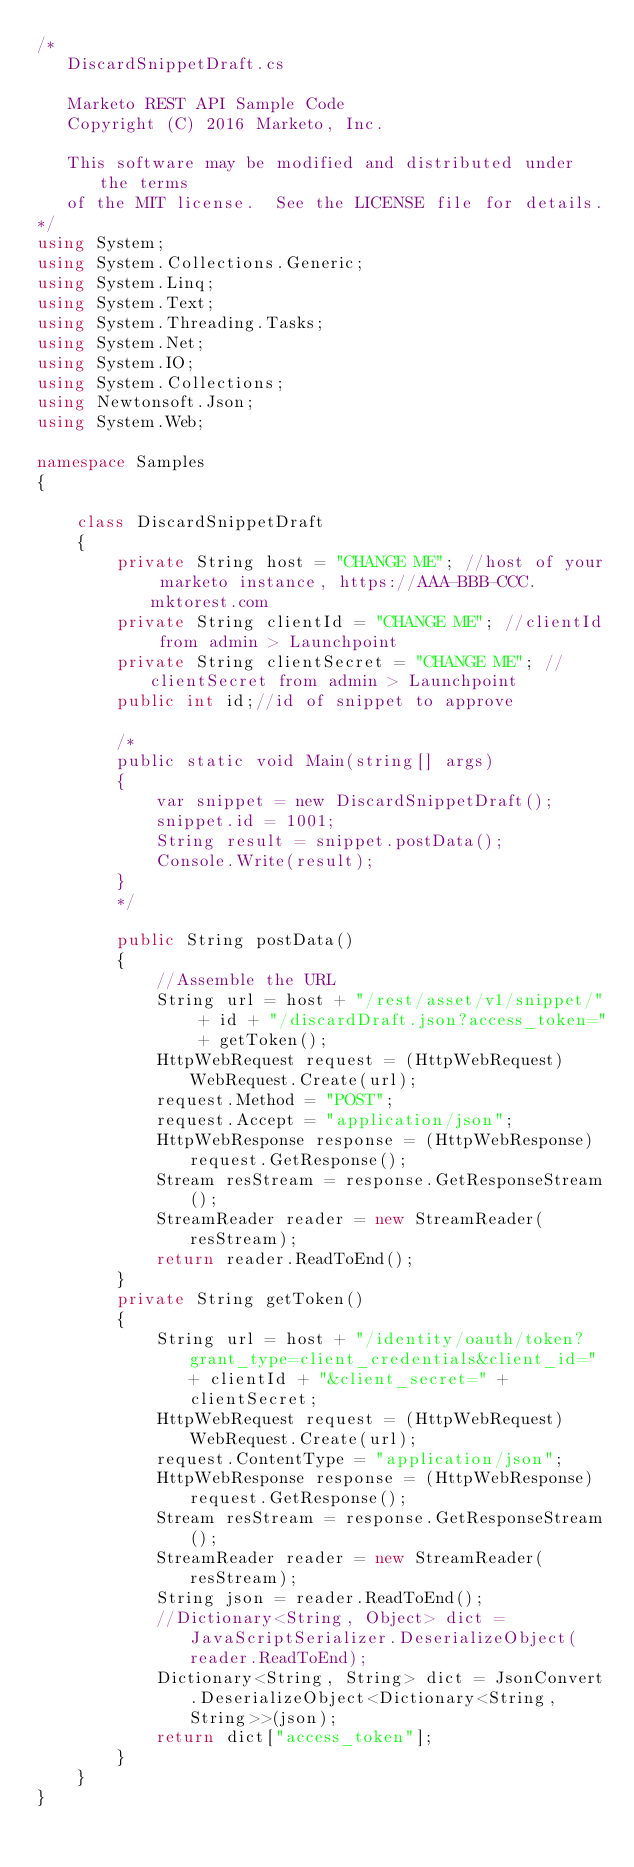Convert code to text. <code><loc_0><loc_0><loc_500><loc_500><_C#_>/*
   DiscardSnippetDraft.cs

   Marketo REST API Sample Code
   Copyright (C) 2016 Marketo, Inc.

   This software may be modified and distributed under the terms
   of the MIT license.  See the LICENSE file for details.
*/
using System;
using System.Collections.Generic;
using System.Linq;
using System.Text;
using System.Threading.Tasks;
using System.Net;
using System.IO;
using System.Collections;
using Newtonsoft.Json;
using System.Web;

namespace Samples
{

    class DiscardSnippetDraft
    {
        private String host = "CHANGE ME"; //host of your marketo instance, https://AAA-BBB-CCC.mktorest.com
        private String clientId = "CHANGE ME"; //clientId from admin > Launchpoint
        private String clientSecret = "CHANGE ME"; //clientSecret from admin > Launchpoint
        public int id;//id of snippet to approve

        /*
        public static void Main(string[] args)
        {
            var snippet = new DiscardSnippetDraft();
            snippet.id = 1001;
            String result = snippet.postData();
            Console.Write(result);
        }
        */

        public String postData()
        {
            //Assemble the URL
            String url = host + "/rest/asset/v1/snippet/" + id + "/discardDraft.json?access_token=" + getToken();
            HttpWebRequest request = (HttpWebRequest)WebRequest.Create(url);
            request.Method = "POST";
            request.Accept = "application/json";
            HttpWebResponse response = (HttpWebResponse)request.GetResponse();
            Stream resStream = response.GetResponseStream();
            StreamReader reader = new StreamReader(resStream);
            return reader.ReadToEnd();
        }
        private String getToken()
        {
            String url = host + "/identity/oauth/token?grant_type=client_credentials&client_id=" + clientId + "&client_secret=" + clientSecret;
            HttpWebRequest request = (HttpWebRequest)WebRequest.Create(url);
            request.ContentType = "application/json";
            HttpWebResponse response = (HttpWebResponse)request.GetResponse();
            Stream resStream = response.GetResponseStream();
            StreamReader reader = new StreamReader(resStream);
            String json = reader.ReadToEnd();
            //Dictionary<String, Object> dict = JavaScriptSerializer.DeserializeObject(reader.ReadToEnd);
            Dictionary<String, String> dict = JsonConvert.DeserializeObject<Dictionary<String, String>>(json);
            return dict["access_token"];
        }
    }
}
</code> 